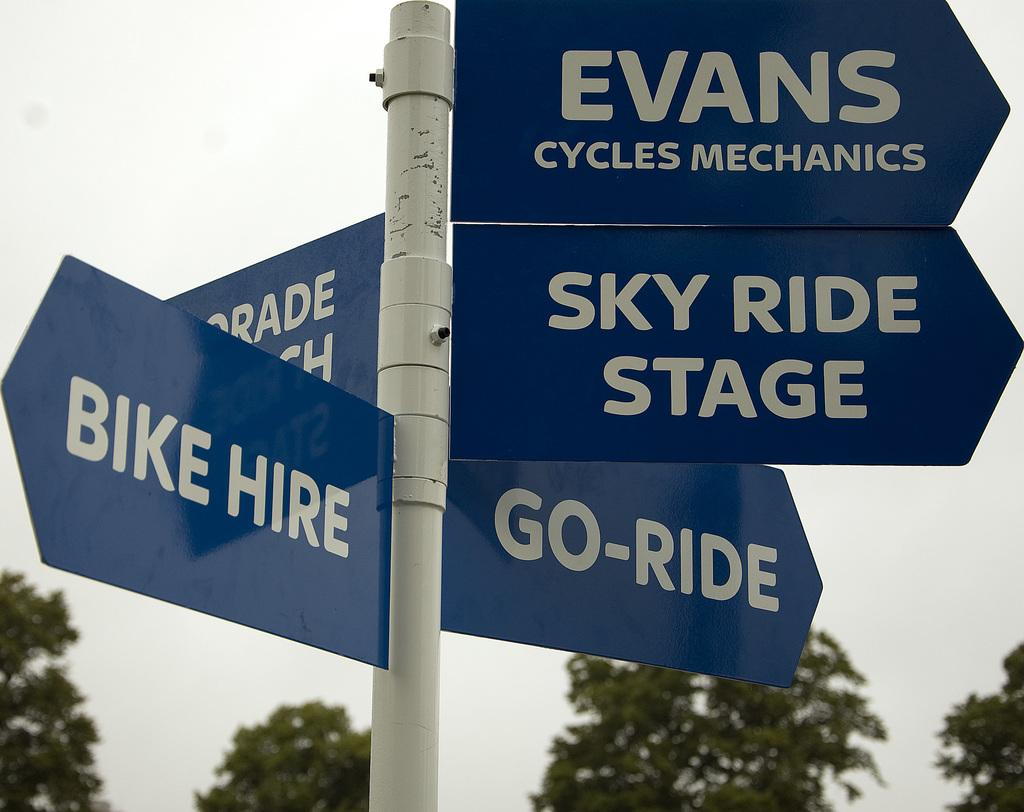Provide a one-sentence caption for the provided image. Direction signs point the way to Evans Cycles Mechanics, Sky Ride Stage, Go-Ride, and Bike Hire. 